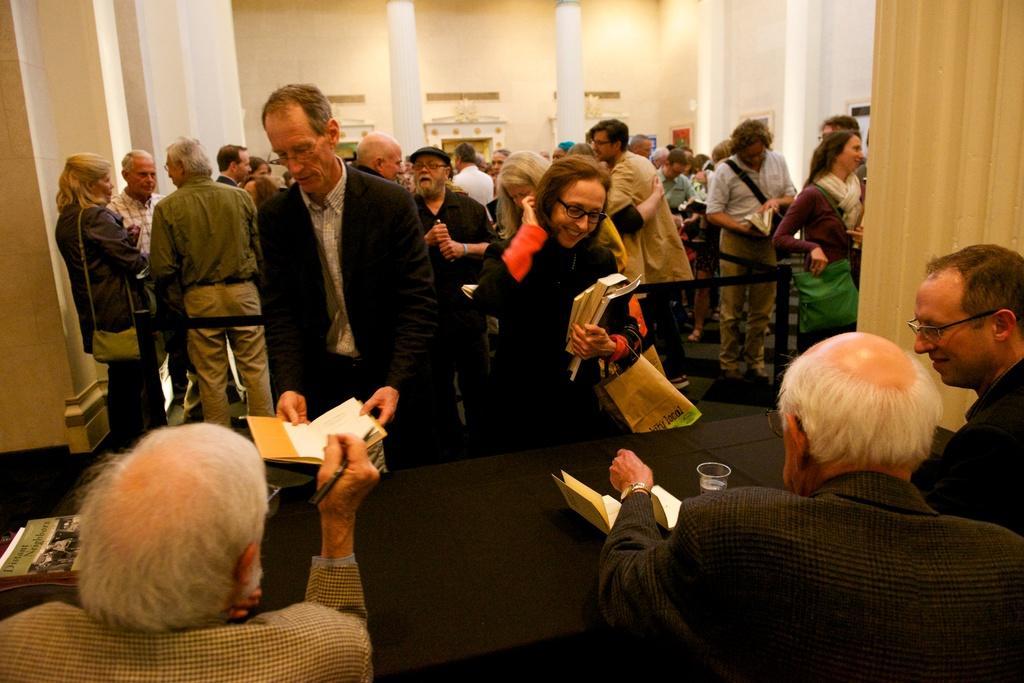In one or two sentences, can you explain what this image depicts? In the image there are three people sitting in front of the table and they are doing some work and there is a lot of the crowd in the room, they are holding some books in their hands and some of them are wearing handbags, behind the crowd there are two pillars and behind the pillars there are some doors and walls. 